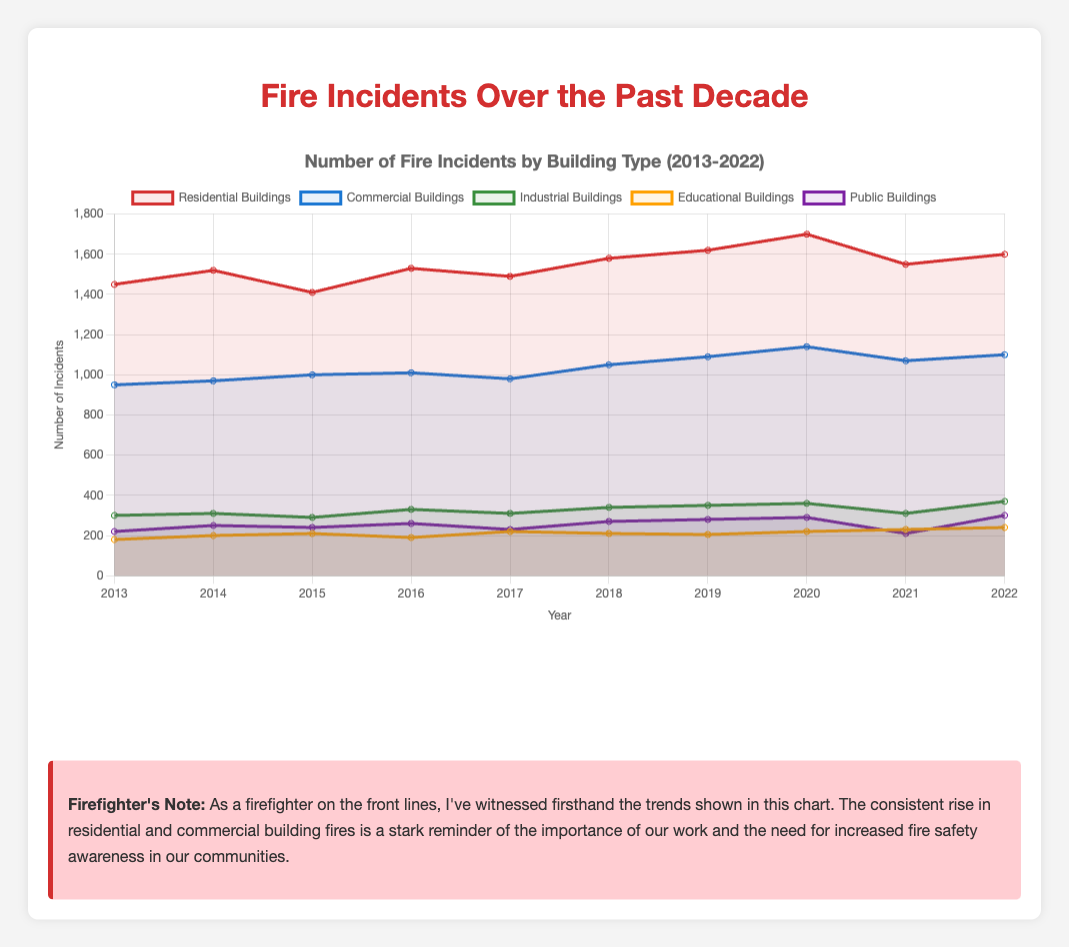Which year had the highest number of fire incidents in residential buildings? Look at the red line representing residential buildings and find the peak value. The peak occurs in the year 2020 with 1700 incidents.
Answer: 2020 Which type of building had fewer fire incidents in 2019, industrial buildings or educational buildings? Compare the data points for industrial buildings and educational buildings for the year 2019. Industrial buildings had 350 incidents, while educational buildings had 205 incidents.
Answer: Educational buildings Which year saw the largest increase in fire incidents for public buildings compared to the previous year? Calculate the annual differences for public buildings between consecutive years: 2014-2013 (30), 2015-2014 (-10), 2016-2015 (20), 2017-2016 (-30), 2018-2017 (40), 2019-2018 (10), 2020-2019 (10), 2021-2020 (-80), 2022-2021 (90). The largest increase is from 2021 to 2022 with 90 more incidents.
Answer: 2022 What is the average number of fire incidents in commercial buildings over the past decade? Sum the number of incidents in commercial buildings from 2013 to 2022 and divide by the number of years: (950 + 970 + 1000 + 1010 + 980 + 1050 + 1090 + 1140 + 1070 + 1100) / 10 = 1036.
Answer: 1036 How did the number of fire incidents in educational buildings change from 2013 to 2022? Compare the incident count in educational buildings for 2013 (180) and 2022 (240). The number increased by (240 - 180) = 60 over this period.
Answer: Increased by 60 In which year did the industrial buildings experience the same number of fire incidents as public buildings? Look for overlapping points on the green line (industrial buildings) and purple line (public buildings). In 2019, both types of buildings had 350 incidents and 280 incidents respectively. No year matches exactly across the dataset.
Answer: None Which type of building had the most consistent number of fire incidents from year to year? Assess the lines' overall stability. The red line (residential), blue line (commercial), and green line (industrial) have noticeable fluctuations. The yellow line (educational) and purple line (public) are relatively more stable. Among them, educational buildings' line is the least variable.
Answer: Educational buildings What was the percentage increase in fire incidents in residential buildings from 2019 to 2020? Calculate the percentage increase: ((1700 - 1620) / 1620) * 100 = 4.94%.
Answer: 4.94% Compare the total number of fire incidents in public buildings and industrial buildings over the decade. Which had more? Sum the number of incidents for each type: Public buildings: (220+250+240+260+230+270+280+290+210+300) = 2550, Industrial buildings: (300+310+290+330+310+340+350+360+310+370) = 3270. Industrial buildings had more.
Answer: Industrial buildings During which years did commercial buildings experience a decline in fire incidents? Examine the blue line for any drops between consecutive years. Declines occurred from 2016 to 2017 and 2020 to 2021.
Answer: 2017, 2021 